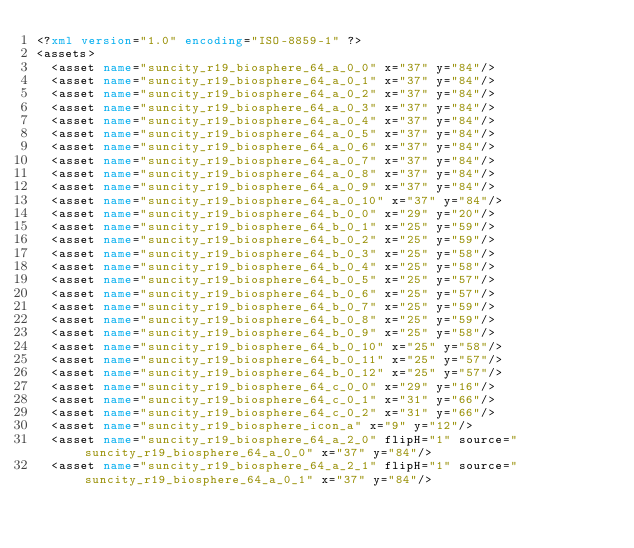Convert code to text. <code><loc_0><loc_0><loc_500><loc_500><_XML_><?xml version="1.0" encoding="ISO-8859-1" ?><assets>
  <asset name="suncity_r19_biosphere_64_a_0_0" x="37" y="84"/>
  <asset name="suncity_r19_biosphere_64_a_0_1" x="37" y="84"/>
  <asset name="suncity_r19_biosphere_64_a_0_2" x="37" y="84"/>
  <asset name="suncity_r19_biosphere_64_a_0_3" x="37" y="84"/>
  <asset name="suncity_r19_biosphere_64_a_0_4" x="37" y="84"/>
  <asset name="suncity_r19_biosphere_64_a_0_5" x="37" y="84"/>
  <asset name="suncity_r19_biosphere_64_a_0_6" x="37" y="84"/>
  <asset name="suncity_r19_biosphere_64_a_0_7" x="37" y="84"/>
  <asset name="suncity_r19_biosphere_64_a_0_8" x="37" y="84"/>
  <asset name="suncity_r19_biosphere_64_a_0_9" x="37" y="84"/>
  <asset name="suncity_r19_biosphere_64_a_0_10" x="37" y="84"/>
  <asset name="suncity_r19_biosphere_64_b_0_0" x="29" y="20"/>
  <asset name="suncity_r19_biosphere_64_b_0_1" x="25" y="59"/>
  <asset name="suncity_r19_biosphere_64_b_0_2" x="25" y="59"/>
  <asset name="suncity_r19_biosphere_64_b_0_3" x="25" y="58"/>
  <asset name="suncity_r19_biosphere_64_b_0_4" x="25" y="58"/>
  <asset name="suncity_r19_biosphere_64_b_0_5" x="25" y="57"/>
  <asset name="suncity_r19_biosphere_64_b_0_6" x="25" y="57"/>
  <asset name="suncity_r19_biosphere_64_b_0_7" x="25" y="59"/>
  <asset name="suncity_r19_biosphere_64_b_0_8" x="25" y="59"/>
  <asset name="suncity_r19_biosphere_64_b_0_9" x="25" y="58"/>
  <asset name="suncity_r19_biosphere_64_b_0_10" x="25" y="58"/>
  <asset name="suncity_r19_biosphere_64_b_0_11" x="25" y="57"/>
  <asset name="suncity_r19_biosphere_64_b_0_12" x="25" y="57"/>
  <asset name="suncity_r19_biosphere_64_c_0_0" x="29" y="16"/>
  <asset name="suncity_r19_biosphere_64_c_0_1" x="31" y="66"/>
  <asset name="suncity_r19_biosphere_64_c_0_2" x="31" y="66"/>
  <asset name="suncity_r19_biosphere_icon_a" x="9" y="12"/>
  <asset name="suncity_r19_biosphere_64_a_2_0" flipH="1" source="suncity_r19_biosphere_64_a_0_0" x="37" y="84"/>
  <asset name="suncity_r19_biosphere_64_a_2_1" flipH="1" source="suncity_r19_biosphere_64_a_0_1" x="37" y="84"/></code> 